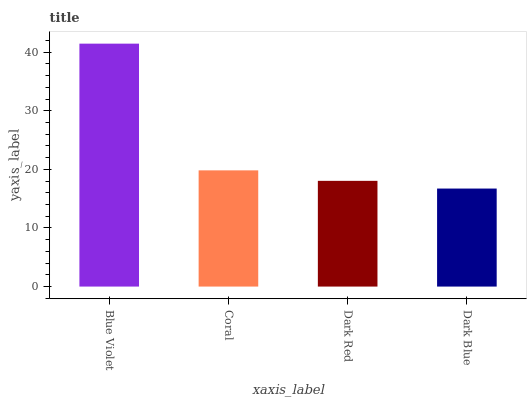Is Dark Blue the minimum?
Answer yes or no. Yes. Is Blue Violet the maximum?
Answer yes or no. Yes. Is Coral the minimum?
Answer yes or no. No. Is Coral the maximum?
Answer yes or no. No. Is Blue Violet greater than Coral?
Answer yes or no. Yes. Is Coral less than Blue Violet?
Answer yes or no. Yes. Is Coral greater than Blue Violet?
Answer yes or no. No. Is Blue Violet less than Coral?
Answer yes or no. No. Is Coral the high median?
Answer yes or no. Yes. Is Dark Red the low median?
Answer yes or no. Yes. Is Blue Violet the high median?
Answer yes or no. No. Is Coral the low median?
Answer yes or no. No. 